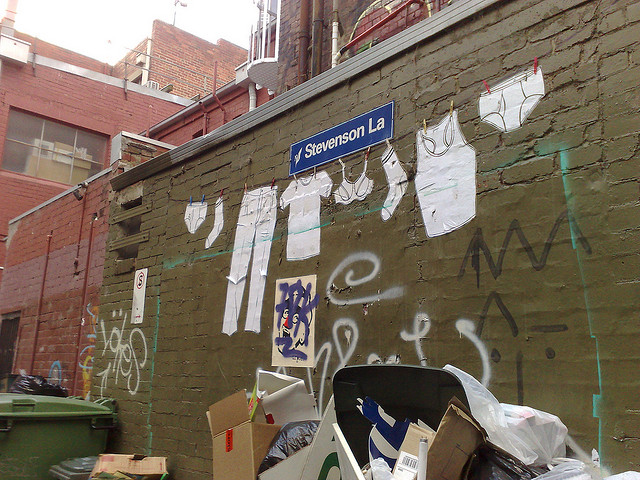<image>Who more than wrote the writings on the wall? It's unknown who wrote the writings on the wall. It could be anyone, like vandals, graffiti artists, or a specific person. Who more than wrote the writings on the wall? I don't know who wrote the writings on the wall. It can be done by different people, delinquents, vandals, graffiti artists or even me. 